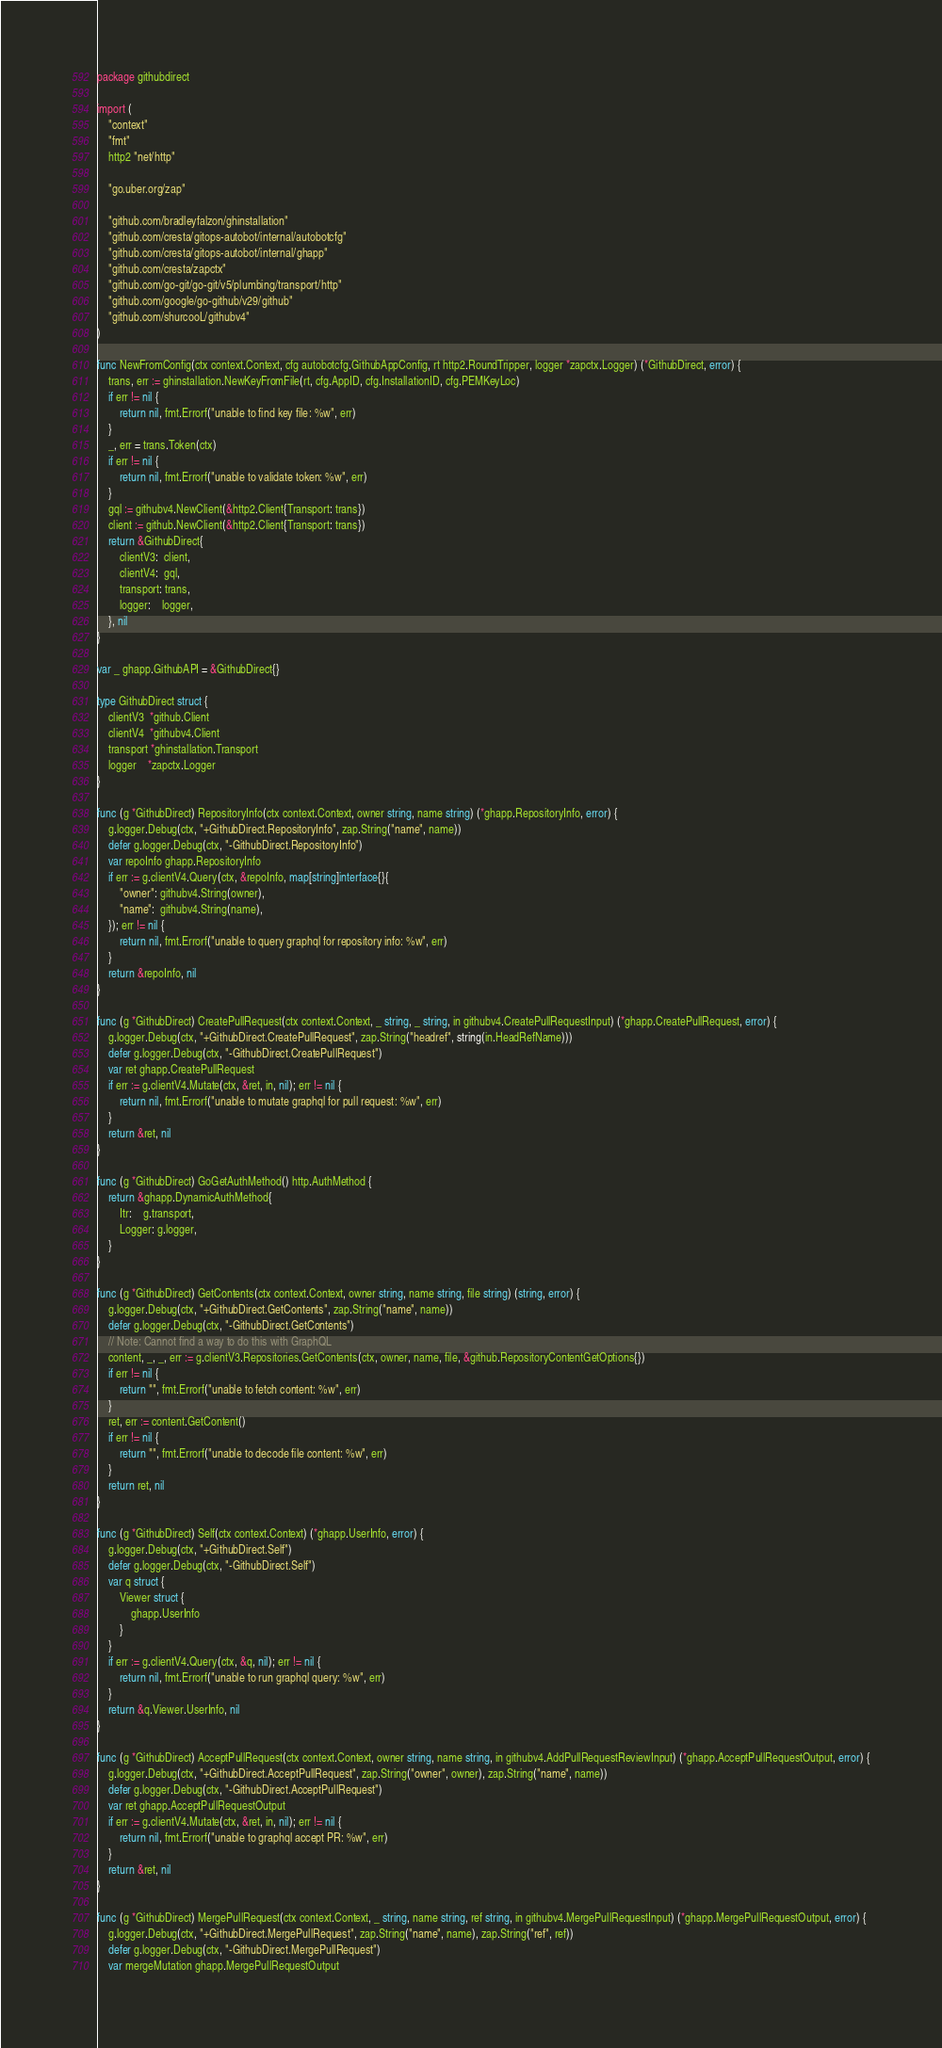<code> <loc_0><loc_0><loc_500><loc_500><_Go_>package githubdirect

import (
	"context"
	"fmt"
	http2 "net/http"

	"go.uber.org/zap"

	"github.com/bradleyfalzon/ghinstallation"
	"github.com/cresta/gitops-autobot/internal/autobotcfg"
	"github.com/cresta/gitops-autobot/internal/ghapp"
	"github.com/cresta/zapctx"
	"github.com/go-git/go-git/v5/plumbing/transport/http"
	"github.com/google/go-github/v29/github"
	"github.com/shurcooL/githubv4"
)

func NewFromConfig(ctx context.Context, cfg autobotcfg.GithubAppConfig, rt http2.RoundTripper, logger *zapctx.Logger) (*GithubDirect, error) {
	trans, err := ghinstallation.NewKeyFromFile(rt, cfg.AppID, cfg.InstallationID, cfg.PEMKeyLoc)
	if err != nil {
		return nil, fmt.Errorf("unable to find key file: %w", err)
	}
	_, err = trans.Token(ctx)
	if err != nil {
		return nil, fmt.Errorf("unable to validate token: %w", err)
	}
	gql := githubv4.NewClient(&http2.Client{Transport: trans})
	client := github.NewClient(&http2.Client{Transport: trans})
	return &GithubDirect{
		clientV3:  client,
		clientV4:  gql,
		transport: trans,
		logger:    logger,
	}, nil
}

var _ ghapp.GithubAPI = &GithubDirect{}

type GithubDirect struct {
	clientV3  *github.Client
	clientV4  *githubv4.Client
	transport *ghinstallation.Transport
	logger    *zapctx.Logger
}

func (g *GithubDirect) RepositoryInfo(ctx context.Context, owner string, name string) (*ghapp.RepositoryInfo, error) {
	g.logger.Debug(ctx, "+GithubDirect.RepositoryInfo", zap.String("name", name))
	defer g.logger.Debug(ctx, "-GithubDirect.RepositoryInfo")
	var repoInfo ghapp.RepositoryInfo
	if err := g.clientV4.Query(ctx, &repoInfo, map[string]interface{}{
		"owner": githubv4.String(owner),
		"name":  githubv4.String(name),
	}); err != nil {
		return nil, fmt.Errorf("unable to query graphql for repository info: %w", err)
	}
	return &repoInfo, nil
}

func (g *GithubDirect) CreatePullRequest(ctx context.Context, _ string, _ string, in githubv4.CreatePullRequestInput) (*ghapp.CreatePullRequest, error) {
	g.logger.Debug(ctx, "+GithubDirect.CreatePullRequest", zap.String("headref", string(in.HeadRefName)))
	defer g.logger.Debug(ctx, "-GithubDirect.CreatePullRequest")
	var ret ghapp.CreatePullRequest
	if err := g.clientV4.Mutate(ctx, &ret, in, nil); err != nil {
		return nil, fmt.Errorf("unable to mutate graphql for pull request: %w", err)
	}
	return &ret, nil
}

func (g *GithubDirect) GoGetAuthMethod() http.AuthMethod {
	return &ghapp.DynamicAuthMethod{
		Itr:    g.transport,
		Logger: g.logger,
	}
}

func (g *GithubDirect) GetContents(ctx context.Context, owner string, name string, file string) (string, error) {
	g.logger.Debug(ctx, "+GithubDirect.GetContents", zap.String("name", name))
	defer g.logger.Debug(ctx, "-GithubDirect.GetContents")
	// Note: Cannot find a way to do this with GraphQL
	content, _, _, err := g.clientV3.Repositories.GetContents(ctx, owner, name, file, &github.RepositoryContentGetOptions{})
	if err != nil {
		return "", fmt.Errorf("unable to fetch content: %w", err)
	}
	ret, err := content.GetContent()
	if err != nil {
		return "", fmt.Errorf("unable to decode file content: %w", err)
	}
	return ret, nil
}

func (g *GithubDirect) Self(ctx context.Context) (*ghapp.UserInfo, error) {
	g.logger.Debug(ctx, "+GithubDirect.Self")
	defer g.logger.Debug(ctx, "-GithubDirect.Self")
	var q struct {
		Viewer struct {
			ghapp.UserInfo
		}
	}
	if err := g.clientV4.Query(ctx, &q, nil); err != nil {
		return nil, fmt.Errorf("unable to run graphql query: %w", err)
	}
	return &q.Viewer.UserInfo, nil
}

func (g *GithubDirect) AcceptPullRequest(ctx context.Context, owner string, name string, in githubv4.AddPullRequestReviewInput) (*ghapp.AcceptPullRequestOutput, error) {
	g.logger.Debug(ctx, "+GithubDirect.AcceptPullRequest", zap.String("owner", owner), zap.String("name", name))
	defer g.logger.Debug(ctx, "-GithubDirect.AcceptPullRequest")
	var ret ghapp.AcceptPullRequestOutput
	if err := g.clientV4.Mutate(ctx, &ret, in, nil); err != nil {
		return nil, fmt.Errorf("unable to graphql accept PR: %w", err)
	}
	return &ret, nil
}

func (g *GithubDirect) MergePullRequest(ctx context.Context, _ string, name string, ref string, in githubv4.MergePullRequestInput) (*ghapp.MergePullRequestOutput, error) {
	g.logger.Debug(ctx, "+GithubDirect.MergePullRequest", zap.String("name", name), zap.String("ref", ref))
	defer g.logger.Debug(ctx, "-GithubDirect.MergePullRequest")
	var mergeMutation ghapp.MergePullRequestOutput</code> 